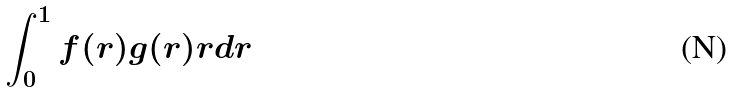<formula> <loc_0><loc_0><loc_500><loc_500>\int _ { 0 } ^ { 1 } f ( r ) g ( r ) r d r</formula> 